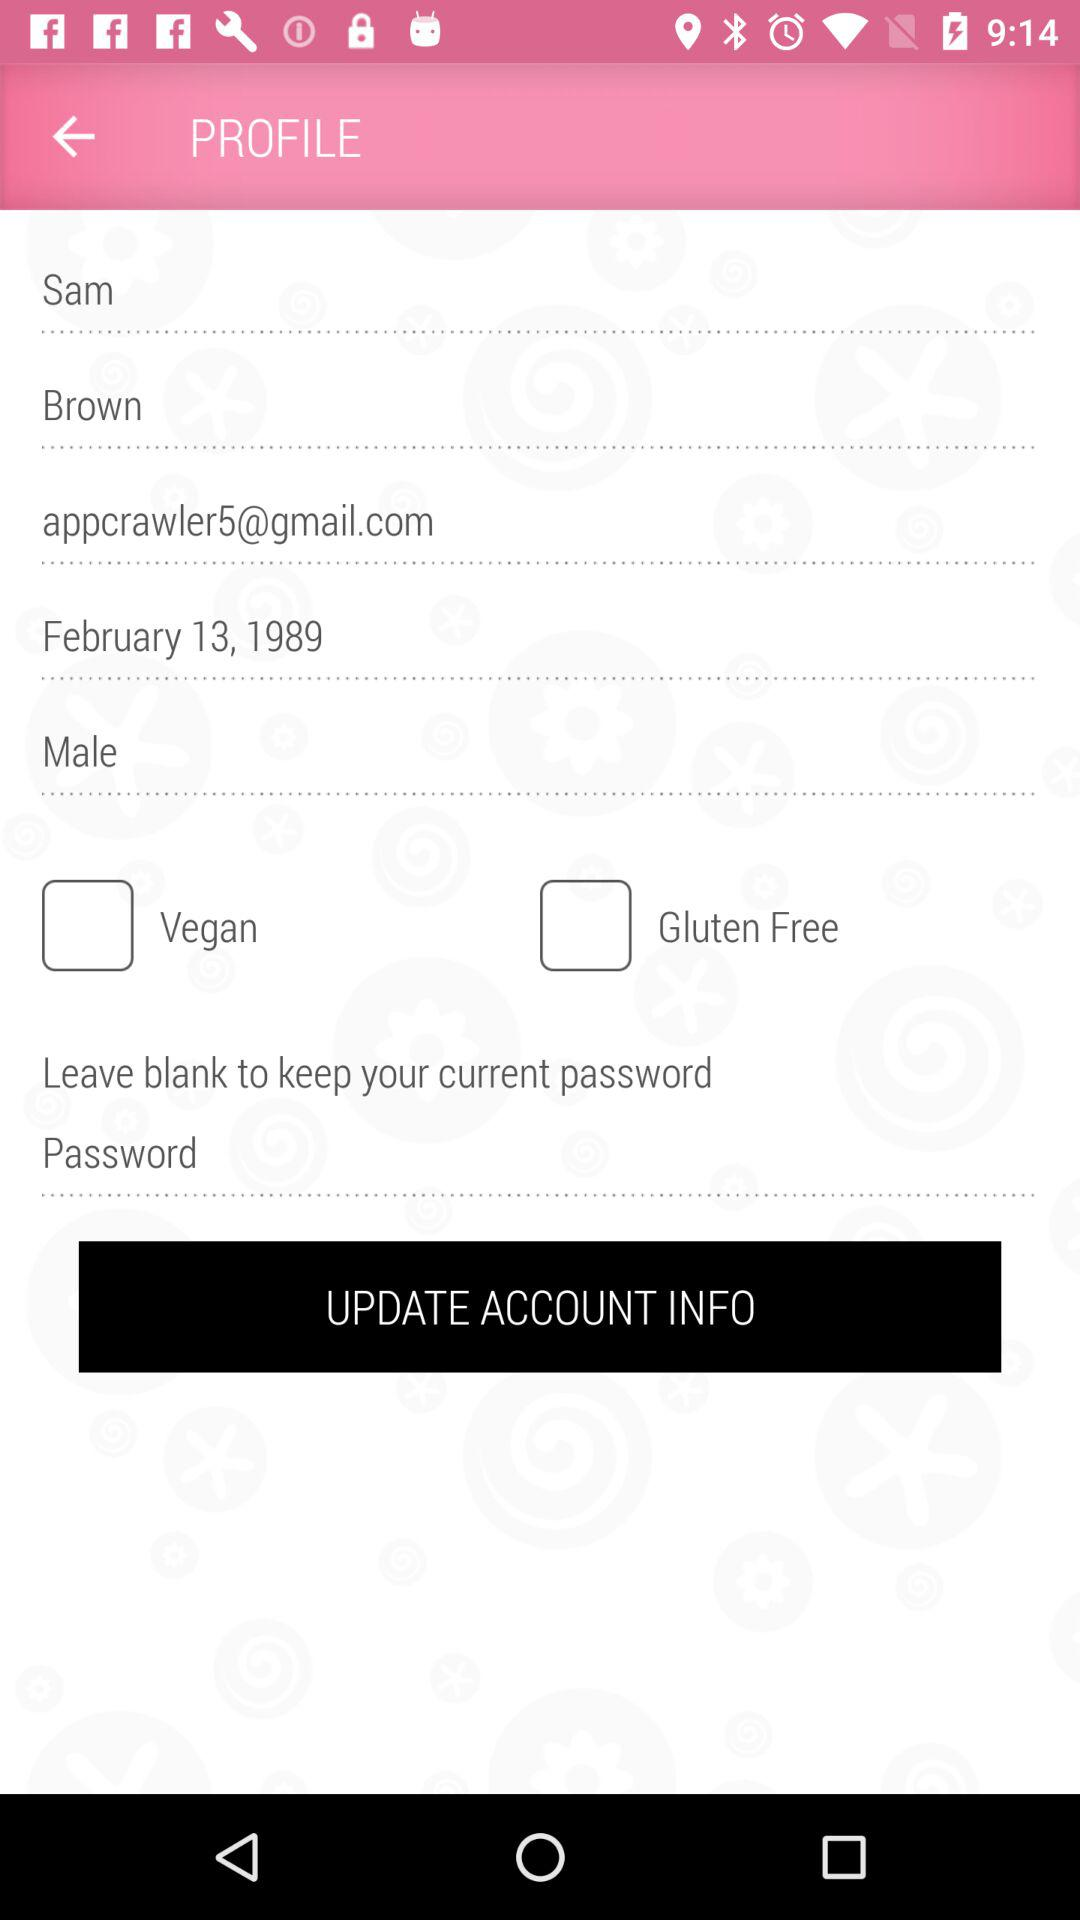What is the status of "Gluten Free"? The status is "off". 